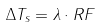<formula> <loc_0><loc_0><loc_500><loc_500>\Delta T _ { s } = \lambda \cdot R F</formula> 